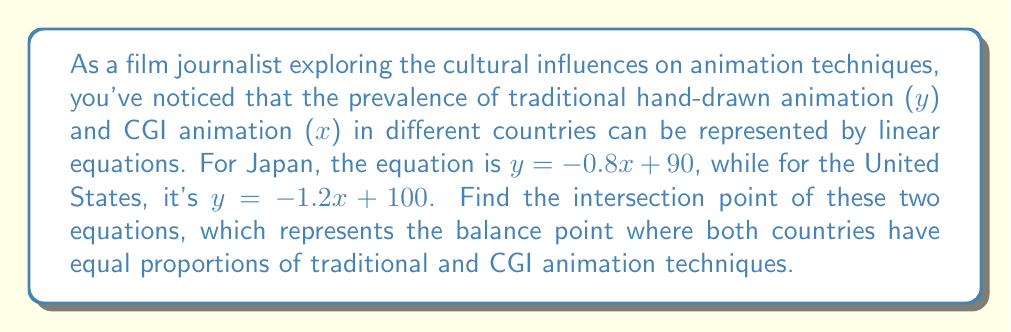Help me with this question. To find the intersection point of these two linear equations, we need to solve them simultaneously:

Equation for Japan: $y = -0.8x + 90$
Equation for USA: $y = -1.2x + 100$

At the intersection point, both equations will have the same x and y values. So, we can set them equal to each other:

$$-0.8x + 90 = -1.2x + 100$$

Now, let's solve for x:

$$-0.8x + 90 = -1.2x + 100$$
$$-0.8x + 1.2x = 100 - 90$$
$$0.4x = 10$$
$$x = 25$$

To find the y-coordinate, we can substitute this x-value into either of the original equations. Let's use Japan's equation:

$$y = -0.8(25) + 90$$
$$y = -20 + 90$$
$$y = 70$$

Therefore, the intersection point is (25, 70).

[asy]
import graph;
size(200);
xaxis("x", -5, 100, arrow=Arrow);
yaxis("y", -5, 100, arrow=Arrow);
draw((0,90)--(100,10), blue, legend="Japan");
draw((0,100)--(83.33,0), red, legend="USA");
dot((25,70), green);
label("(25, 70)", (25,70), SE);
[/asy]
Answer: The intersection point is (25, 70). This means that when 25% of animation is CGI, both countries will have 70% traditional hand-drawn animation, representing the balance point between the two techniques. 